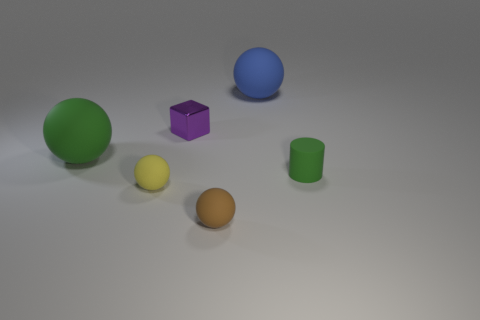Add 3 big gray things. How many objects exist? 9 Subtract all red balls. Subtract all blue cylinders. How many balls are left? 4 Subtract all blocks. How many objects are left? 5 Subtract all matte balls. Subtract all small shiny objects. How many objects are left? 1 Add 6 cylinders. How many cylinders are left? 7 Add 5 green rubber things. How many green rubber things exist? 7 Subtract 0 brown cylinders. How many objects are left? 6 